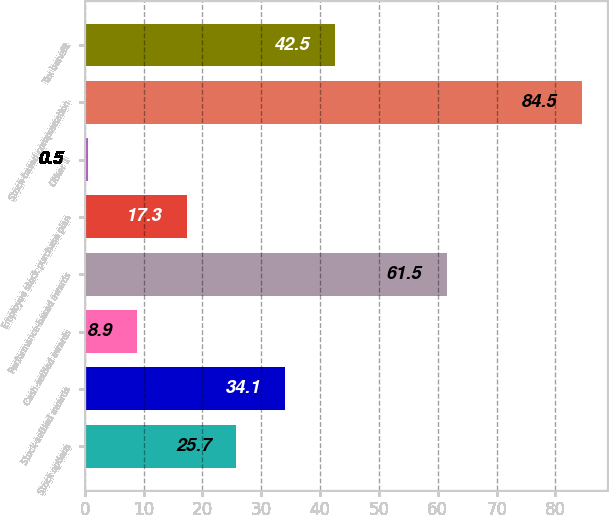Convert chart. <chart><loc_0><loc_0><loc_500><loc_500><bar_chart><fcel>Stock options<fcel>Stock-settled awards<fcel>Cash-settled awards<fcel>Performance-based awards<fcel>Employee stock purchase plan<fcel>Other 1<fcel>Stock-based compensation<fcel>Tax benefit<nl><fcel>25.7<fcel>34.1<fcel>8.9<fcel>61.5<fcel>17.3<fcel>0.5<fcel>84.5<fcel>42.5<nl></chart> 